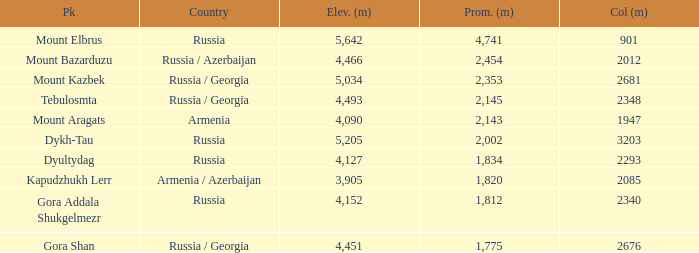What is the Col (m) of Peak Mount Aragats with an Elevation (m) larger than 3,905 and Prominence smaller than 2,143? None. 